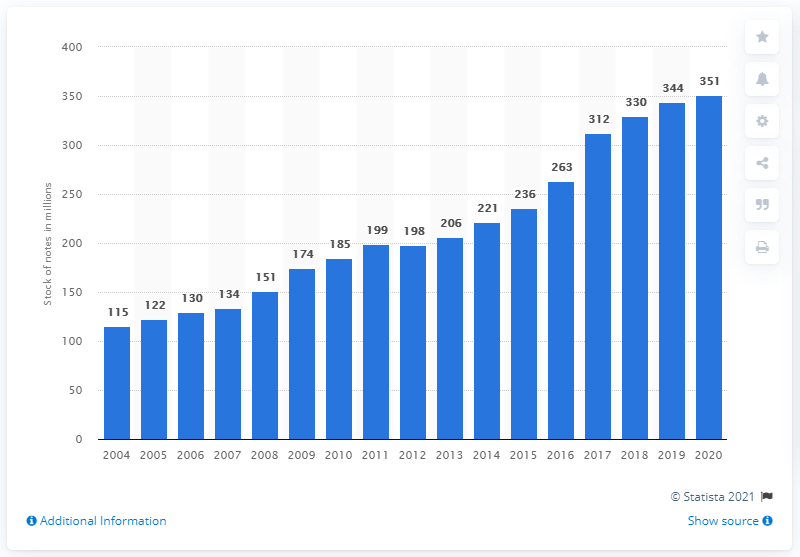List a handful of essential elements in this visual. There were 236 British pound banknotes in circulation between 2004 and 2020. 